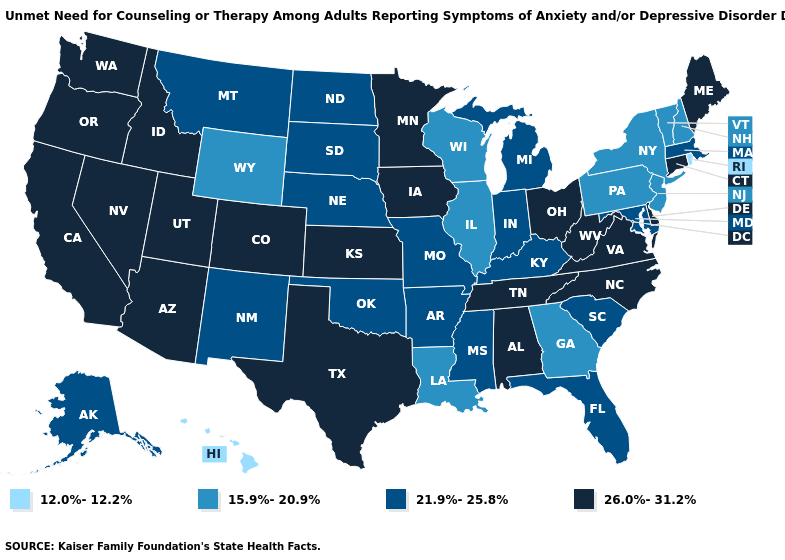What is the value of Connecticut?
Keep it brief. 26.0%-31.2%. What is the value of Utah?
Short answer required. 26.0%-31.2%. What is the value of Kentucky?
Write a very short answer. 21.9%-25.8%. Name the states that have a value in the range 12.0%-12.2%?
Short answer required. Hawaii, Rhode Island. Among the states that border Tennessee , does Missouri have the lowest value?
Concise answer only. No. Name the states that have a value in the range 12.0%-12.2%?
Quick response, please. Hawaii, Rhode Island. What is the highest value in the South ?
Answer briefly. 26.0%-31.2%. Which states have the lowest value in the South?
Write a very short answer. Georgia, Louisiana. Name the states that have a value in the range 26.0%-31.2%?
Write a very short answer. Alabama, Arizona, California, Colorado, Connecticut, Delaware, Idaho, Iowa, Kansas, Maine, Minnesota, Nevada, North Carolina, Ohio, Oregon, Tennessee, Texas, Utah, Virginia, Washington, West Virginia. What is the value of Kentucky?
Short answer required. 21.9%-25.8%. Which states hav the highest value in the Northeast?
Quick response, please. Connecticut, Maine. What is the value of Mississippi?
Write a very short answer. 21.9%-25.8%. Does the map have missing data?
Write a very short answer. No. Among the states that border Arkansas , which have the highest value?
Concise answer only. Tennessee, Texas. Name the states that have a value in the range 12.0%-12.2%?
Keep it brief. Hawaii, Rhode Island. 